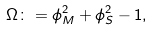<formula> <loc_0><loc_0><loc_500><loc_500>\Omega \colon = \phi _ { M } ^ { 2 } + \phi _ { S } ^ { 2 } - 1 ,</formula> 